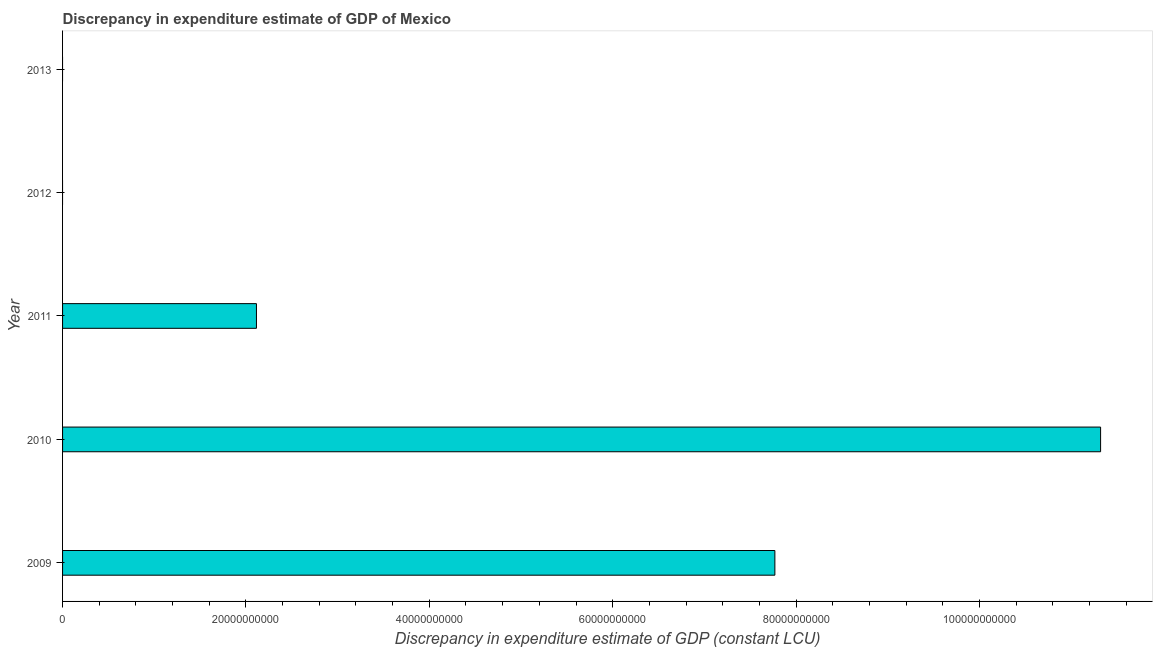What is the title of the graph?
Your answer should be very brief. Discrepancy in expenditure estimate of GDP of Mexico. What is the label or title of the X-axis?
Keep it short and to the point. Discrepancy in expenditure estimate of GDP (constant LCU). What is the discrepancy in expenditure estimate of gdp in 2011?
Your response must be concise. 2.11e+1. Across all years, what is the maximum discrepancy in expenditure estimate of gdp?
Provide a succinct answer. 1.13e+11. Across all years, what is the minimum discrepancy in expenditure estimate of gdp?
Make the answer very short. 0. What is the sum of the discrepancy in expenditure estimate of gdp?
Ensure brevity in your answer.  2.12e+11. What is the difference between the discrepancy in expenditure estimate of gdp in 2009 and 2011?
Your response must be concise. 5.65e+1. What is the average discrepancy in expenditure estimate of gdp per year?
Offer a terse response. 4.24e+1. What is the median discrepancy in expenditure estimate of gdp?
Your response must be concise. 2.11e+1. Is the discrepancy in expenditure estimate of gdp in 2009 less than that in 2011?
Offer a very short reply. No. What is the difference between the highest and the second highest discrepancy in expenditure estimate of gdp?
Your response must be concise. 3.55e+1. What is the difference between the highest and the lowest discrepancy in expenditure estimate of gdp?
Make the answer very short. 1.13e+11. How many bars are there?
Keep it short and to the point. 3. How many years are there in the graph?
Your answer should be very brief. 5. Are the values on the major ticks of X-axis written in scientific E-notation?
Ensure brevity in your answer.  No. What is the Discrepancy in expenditure estimate of GDP (constant LCU) of 2009?
Ensure brevity in your answer.  7.77e+1. What is the Discrepancy in expenditure estimate of GDP (constant LCU) of 2010?
Give a very brief answer. 1.13e+11. What is the Discrepancy in expenditure estimate of GDP (constant LCU) in 2011?
Your answer should be very brief. 2.11e+1. What is the Discrepancy in expenditure estimate of GDP (constant LCU) in 2012?
Your response must be concise. 0. What is the Discrepancy in expenditure estimate of GDP (constant LCU) in 2013?
Keep it short and to the point. 0. What is the difference between the Discrepancy in expenditure estimate of GDP (constant LCU) in 2009 and 2010?
Your answer should be very brief. -3.55e+1. What is the difference between the Discrepancy in expenditure estimate of GDP (constant LCU) in 2009 and 2011?
Offer a terse response. 5.65e+1. What is the difference between the Discrepancy in expenditure estimate of GDP (constant LCU) in 2010 and 2011?
Offer a very short reply. 9.21e+1. What is the ratio of the Discrepancy in expenditure estimate of GDP (constant LCU) in 2009 to that in 2010?
Your answer should be very brief. 0.69. What is the ratio of the Discrepancy in expenditure estimate of GDP (constant LCU) in 2009 to that in 2011?
Your answer should be compact. 3.67. What is the ratio of the Discrepancy in expenditure estimate of GDP (constant LCU) in 2010 to that in 2011?
Your answer should be compact. 5.35. 